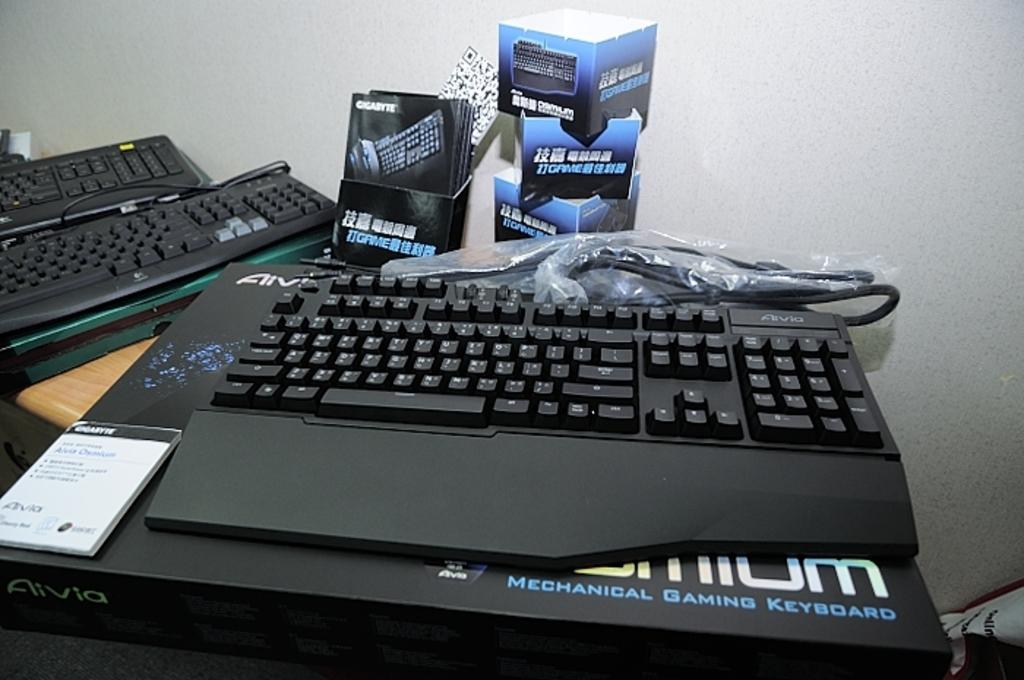Provide a one-sentence caption for the provided image. A mechanical gaming keyboard sits on a desk beside two other keyboards and packaging. 